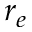<formula> <loc_0><loc_0><loc_500><loc_500>r _ { e }</formula> 